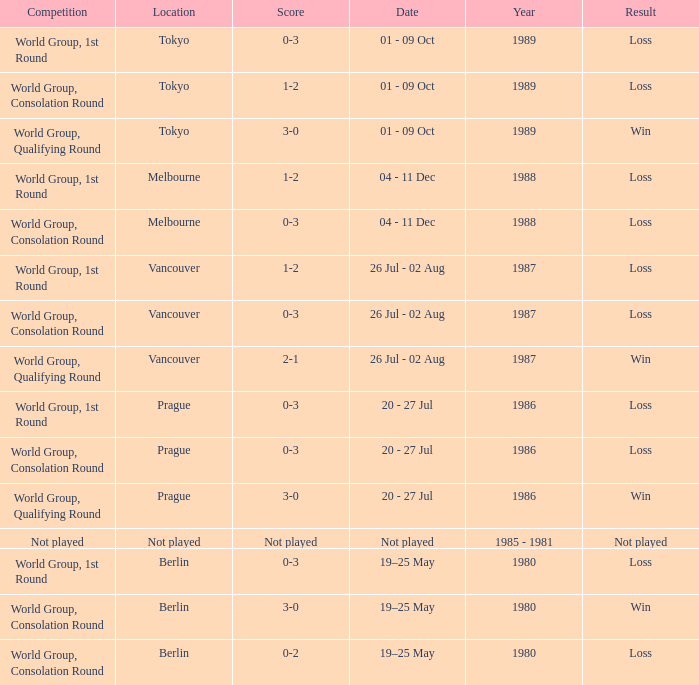What is the score when the result is loss, the year is 1980 and the competition is world group, consolation round? 0-2. 